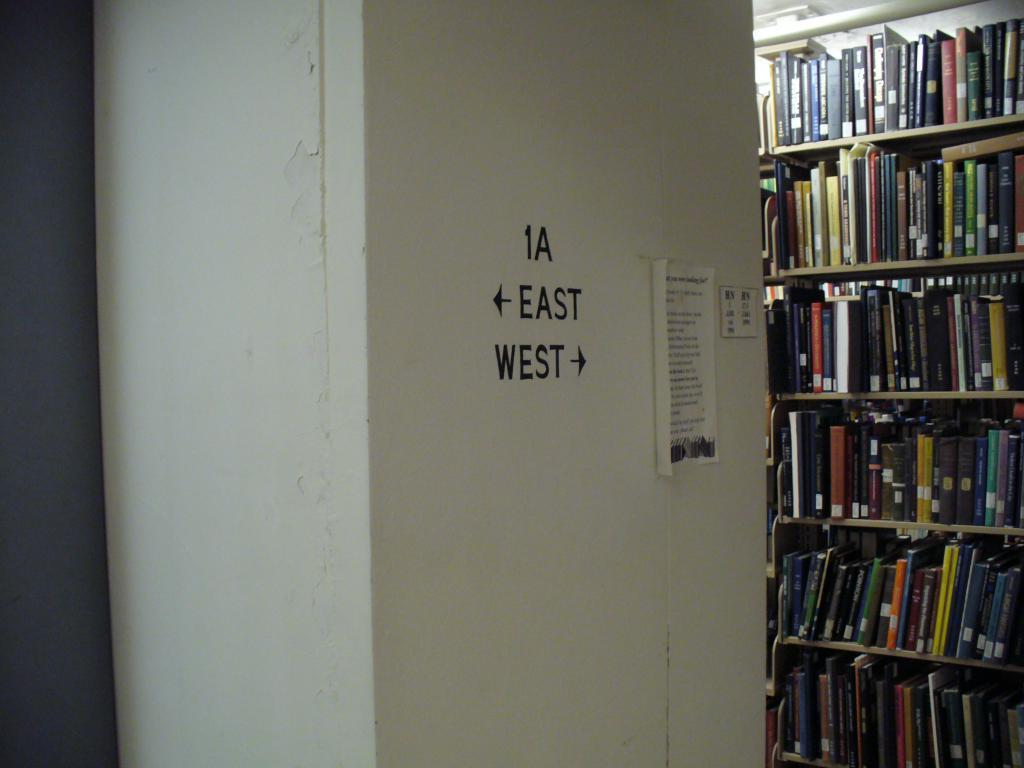<image>
Present a compact description of the photo's key features. the interior of a library with 1A East West on a pillar 